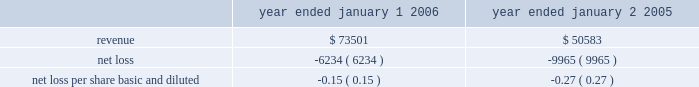In accordance with sfas no .
142 , goodwill and other intangible assets , the goodwill is not amortized , but will be subject to a periodic assessment for impairment by applying a fair-value-based test .
None of this goodwill is expected to be deductible for tax purposes .
The company performs its annual test for impairment of goodwill in may of each year .
The company is required to perform a periodic assessment between annual tests in certain circumstances .
The company has performed its annual test of goodwill as of may 1 , 2006 and has determined there was no impairment of goodwill during 2006 .
The company allocated $ 15.8 million of the purchase price to in-process research and development projects .
In-process research and development ( ipr&d ) represents the valuation of acquired , to-be- completed research projects .
At the acquisition date , cyvera 2019s ongoing research and development initiatives were primarily involved with the development of its veracode technology and the beadxpress reader .
These two projects were approximately 50% ( 50 % ) and 25% ( 25 % ) complete at the date of acquisition , respectively .
As of december 31 , 2006 , these two projects were approximately 90% ( 90 % ) and 80% ( 80 % ) complete , respectively .
The value assigned to purchased ipr&d was determined by estimating the costs to develop the acquired technology into commercially viable products , estimating the resulting net cash flows from the projects , and discounting the net cash flows to their present value .
The revenue projections used to value the ipr&d were , in some cases , reduced based on the probability of developing a new technology , and considered the relevant market sizes and growth factors , expected trends in technology , and the nature and expected timing of new product introductions by the company and its competitors .
The resulting net cash flows from such projects are based on the company 2019s estimates of cost of sales , operating expenses , and income taxes from such projects .
The rates utilized to discount the net cash flows to their present value were based on estimated cost of capital calculations .
Due to the nature of the forecast and the risks associated with the projected growth and profitability of the developmental projects , discount rates of 30% ( 30 % ) were considered appropriate for the ipr&d .
The company believes that these discount rates were commensurate with the projects 2019stage of development and the uncertainties in the economic estimates described above .
If these projects are not successfully developed , the sales and profitability of the combined company may be adversely affected in future periods .
The company believes that the foregoing assumptions used in the ipr&d analysis were reasonable at the time of the acquisition .
No assurance can be given , however , that the underlying assumptions used to estimate expected project sales , development costs or profitability , or the events associated with such projects , will transpire as estimated .
At the date of acquisition , the development of these projects had not yet reached technological feasibility , and the research and development in progress had no alternative future uses .
Accordingly , these costs were charged to expense in the second quarter of 2005 .
The following unaudited pro forma information shows the results of the company 2019s operations for the years ended january 1 , 2006 and january 2 , 2005 as though the acquisition had occurred as of the beginning of the periods presented ( in thousands , except per share data ) : year ended january 1 , year ended january 2 .
Illumina , inc .
Notes to consolidated financial statements 2014 ( continued ) .
What was the percent of the growth in the revenues from 2005 to 2006? 
Rationale: the revenues increased by 45.3% from 2005 to 2006
Computations: ((73501 - 50583) / 50583)
Answer: 0.45308. 